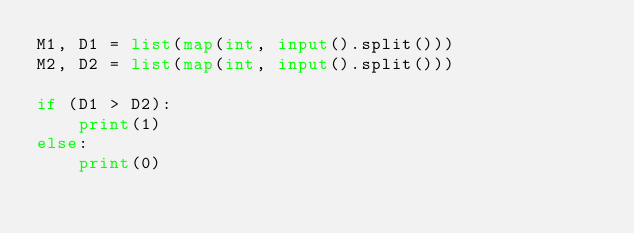Convert code to text. <code><loc_0><loc_0><loc_500><loc_500><_Python_>M1, D1 = list(map(int, input().split()))
M2, D2 = list(map(int, input().split()))

if (D1 > D2):
    print(1)
else:
    print(0)</code> 